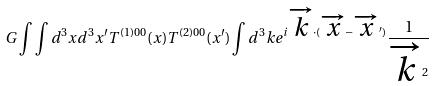<formula> <loc_0><loc_0><loc_500><loc_500>G \int \int d ^ { 3 } x d ^ { 3 } x ^ { \prime } T ^ { ( 1 ) 0 0 } ( x ) T ^ { ( 2 ) 0 0 } ( x ^ { \prime } ) \int d ^ { 3 } k e ^ { i \overrightarrow { k } \cdot ( \overrightarrow { x } - \overrightarrow { x } ^ { \prime } ) } \frac { 1 } { \overrightarrow { k } ^ { 2 } }</formula> 